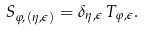Convert formula to latex. <formula><loc_0><loc_0><loc_500><loc_500>S _ { \varphi , ( \eta , \epsilon ) } = \delta _ { \eta , \epsilon } \, T _ { \varphi , \epsilon } .</formula> 